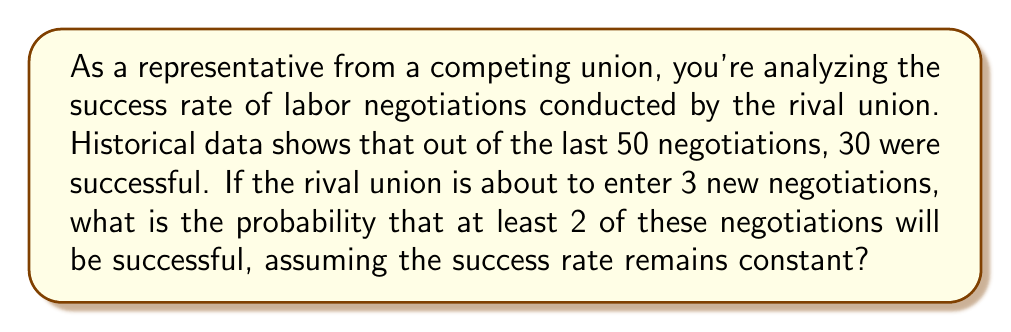Give your solution to this math problem. To solve this problem, we'll use the binomial probability distribution:

1) First, calculate the probability of success for a single negotiation:
   $p = \frac{30}{50} = 0.6$

2) The probability of failure is:
   $q = 1 - p = 0.4$

3) We want the probability of at least 2 successes out of 3 negotiations. This is equal to the probability of exactly 2 successes plus the probability of 3 successes.

4) Use the binomial probability formula:
   $$P(X = k) = \binom{n}{k} p^k q^{n-k}$$
   where $n$ is the number of trials, $k$ is the number of successes.

5) For exactly 2 successes:
   $$P(X = 2) = \binom{3}{2} (0.6)^2 (0.4)^1 = 3 \cdot 0.36 \cdot 0.4 = 0.432$$

6) For exactly 3 successes:
   $$P(X = 3) = \binom{3}{3} (0.6)^3 (0.4)^0 = 1 \cdot 0.216 \cdot 1 = 0.216$$

7) The probability of at least 2 successes is the sum of these probabilities:
   $$P(X \geq 2) = P(X = 2) + P(X = 3) = 0.432 + 0.216 = 0.648$$
Answer: 0.648 